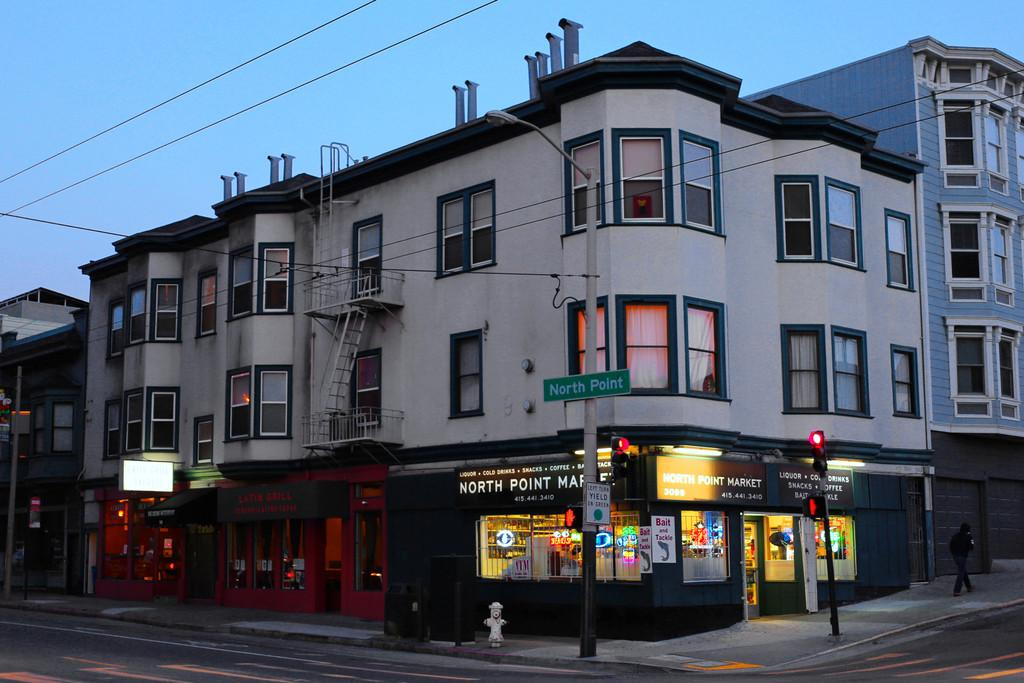What is the main subject in the center of the image? There are buildings in the center of the image. What is located at the bottom of the image? There is a road at the bottom of the image. What can be found on the road in the image? A hydrant is visible on the road. What else is present in the image besides buildings and the road? There are poles and wires at the top of the image. What is visible at the top of the image? The sky is visible at the top of the image. What year is depicted in the image? The image does not depict a specific year; it is a static representation of the scene. Can you tell me how many pockets are visible in the image? There are no pockets visible in the image. 